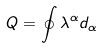<formula> <loc_0><loc_0><loc_500><loc_500>Q = \oint \lambda ^ { \alpha } d _ { \alpha }</formula> 